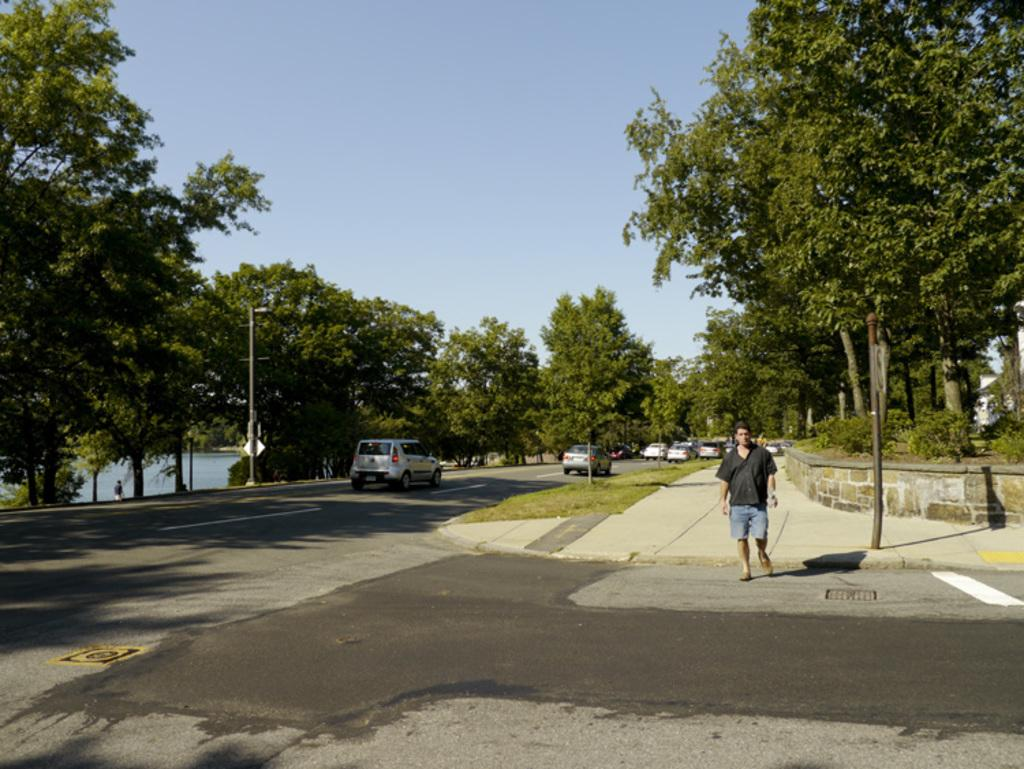What is the man in the image doing? The man is standing on the road in the image. What else can be seen on the road in the image? There are vehicles on the road in the image. What type of vegetation is present in the image? There are trees and plants in the image. What structures are present in the image? There are poles in the image. What is visible in the background of the image? The sky is visible in the background of the image. What type of sheet is covering the trees in the image? There is no sheet covering the trees in the image; the trees are not covered. What is the man using to write on the quill in the image? There is no quill present in the image; the man is simply standing on the road. 